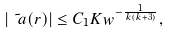<formula> <loc_0><loc_0><loc_500><loc_500>| \tilde { \ a } ( r ) | \leq C _ { 1 } K w ^ { - \frac { 1 } { k ( k + 3 ) } } ,</formula> 